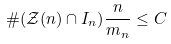<formula> <loc_0><loc_0><loc_500><loc_500>\# ( \mathcal { Z } ( n ) \cap I _ { n } ) \frac { n } { m _ { n } } \leq C</formula> 